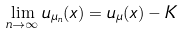<formula> <loc_0><loc_0><loc_500><loc_500>\lim _ { n \to \infty } u _ { \mu _ { n } } ( x ) = u _ { \mu } ( x ) - K</formula> 